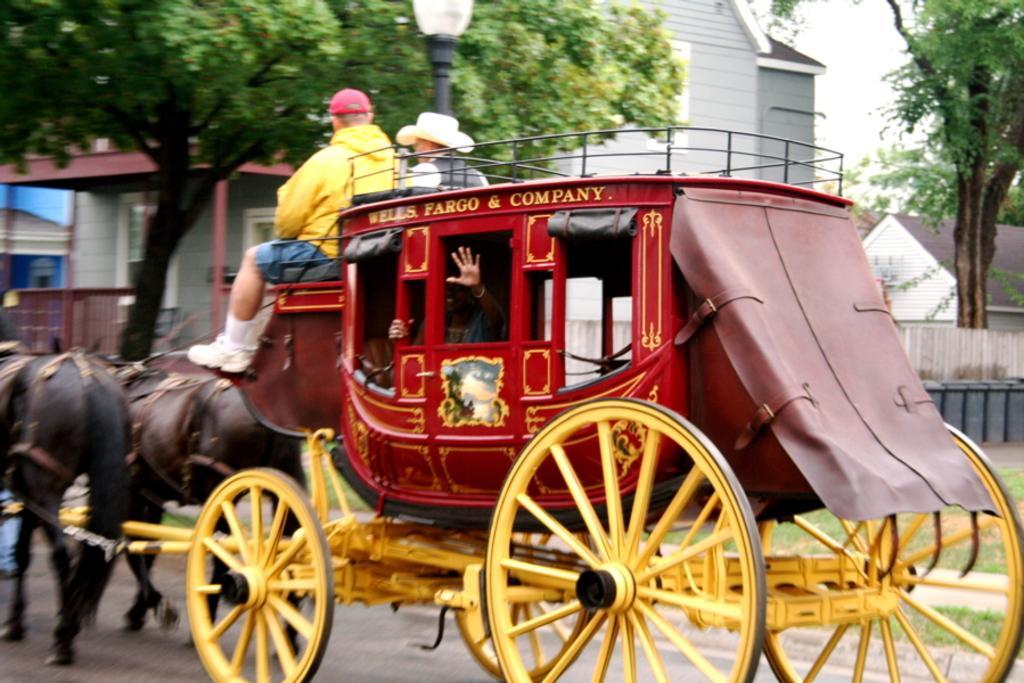How would you summarize this image in a sentence or two? In this picture there are three person riding a chariot with the help of two black horses. This chariot is in red and yellow color. On the background there is a grey building. Here it's a window and door, there is a fencing in front of the house. Here it's a sky. On the Right side there is a tree. Here it's a grass. 